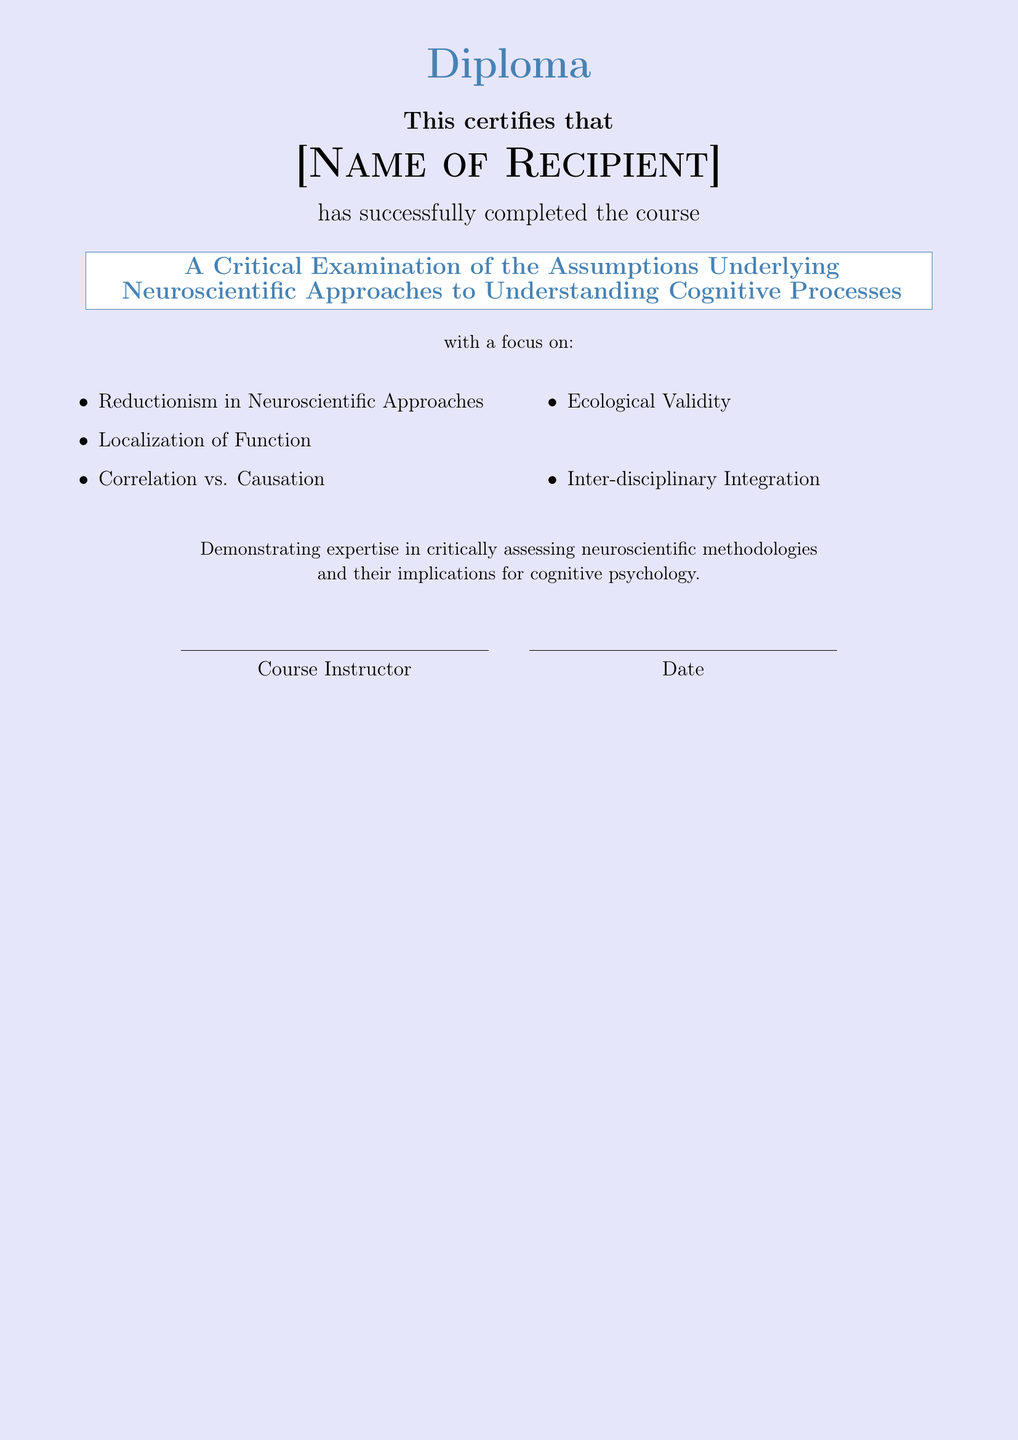What is the recipient's title? The title is prominently displayed in the document, specifying the course completed by the recipient.
Answer: Diploma What is the name of the recipient? The document has a placeholder for the name of the individual who completed the course.
Answer: [Name of Recipient] What is the focus of the course? The document clearly lists the topic of focus regarding the assumptions underlying neuroscientific approaches.
Answer: A Critical Examination of the Assumptions Underlying Neuroscientific Approaches to Understanding Cognitive Processes Who is responsible for issuing the diploma? The document includes a section where the course instructor's name is indicated.
Answer: Course Instructor What date is mentioned in the document? The date of certification is provided in a specific section of the diploma, denoted as a placeholder.
Answer: Date What are two focal points listed in the course content? The document lists several key themes pertaining to the assumptions in neuroscientific approaches, which can be found in an itemized list.
Answer: Reductionism, Localization of Function What is the color of the document background? The document specifies a background color that sets the visual theme for the certification.
Answer: secondcolor What does the diploma certify the recipient for? The document indicates the purpose of the certification.
Answer: successfully completed the course What does the diploma imply about the recipient's expertise? The last part of the document describes the proficiency the recipient demonstrates through the course.
Answer: critically assessing neuroscientific methodologies 